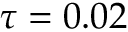Convert formula to latex. <formula><loc_0><loc_0><loc_500><loc_500>\tau = 0 . 0 2</formula> 